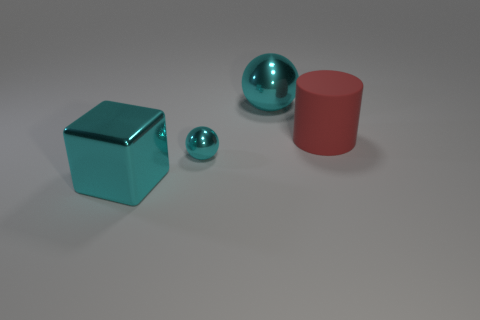There is a large thing that is made of the same material as the large block; what is its color?
Your answer should be very brief. Cyan. Is there a brown sphere of the same size as the rubber thing?
Provide a succinct answer. No. How many things are either objects in front of the red matte cylinder or big blocks to the left of the big cyan metal ball?
Keep it short and to the point. 2. There is a red rubber thing that is the same size as the shiny block; what shape is it?
Offer a very short reply. Cylinder. Is there a big red metal thing of the same shape as the small cyan thing?
Give a very brief answer. No. Are there fewer blue rubber cylinders than tiny cyan things?
Offer a terse response. Yes. There is a shiny sphere that is behind the big matte object; does it have the same size as the cyan object that is in front of the small object?
Offer a terse response. Yes. What number of objects are small green spheres or metal things?
Ensure brevity in your answer.  3. There is a object behind the large red matte cylinder; how big is it?
Provide a succinct answer. Large. There is a cyan object in front of the sphere in front of the large cyan metallic sphere; what number of big cyan metallic things are on the left side of it?
Make the answer very short. 0. 